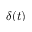<formula> <loc_0><loc_0><loc_500><loc_500>\delta ( t )</formula> 